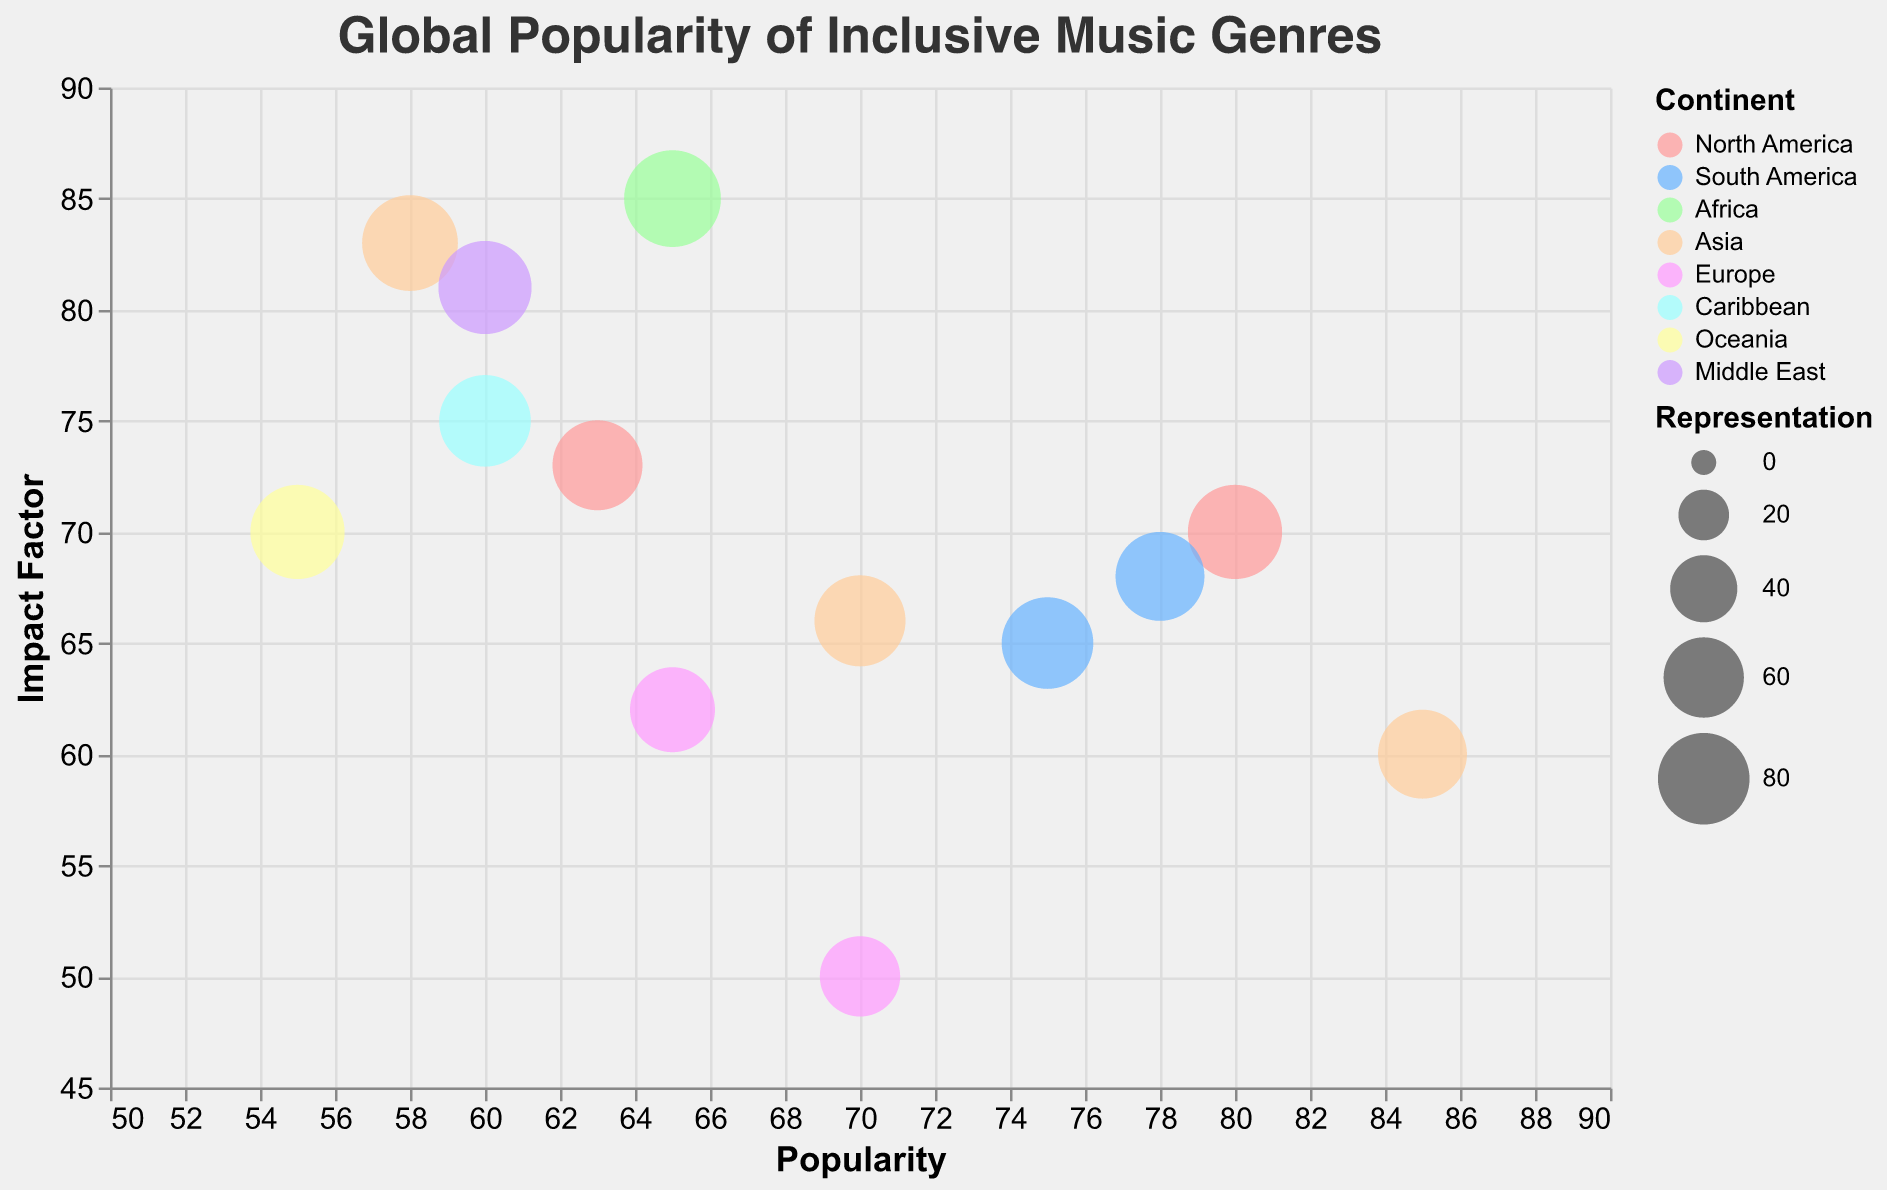What is the title of the chart? The title is usually at the top of the chart, and in this figure, it is "Global Popularity of Inclusive Music Genres".
Answer: Global Popularity of Inclusive Music Genres Which music genre has the highest popularity? To find the music genre with the highest popularity, check the x-axis values and identify the bubble that is furthest to the right. The genre "K-Pop" has the highest popularity at a value of 85.
Answer: K-Pop How many genres are represented by bubbles from Asia? The color legend differentiates continents, and Asia is represented by the orange color. By counting the bubbles of this color, we can see that Asia is represented by three genres: K-Pop, Bhangra, and J-Pop.
Answer: 3 Which genre has the largest representation? The size of each bubble represents the representation value. The largest bubble on the chart corresponds to the genre "Afrobeat" with a representation value of 90.
Answer: Afrobeat Which genre from North America has a higher impact factor? North America is represented by light red bubbles. By comparing the Impact Factor values on the y-axis for "Hip Hop" and "Gospel", we see that "Hip Hop" has an impact factor of 70 while "Gospel" has 73. Thus, "Gospel" has the higher impact factor.
Answer: Gospel Out of Latin Pop and Tropical House, which one has higher popularity and by how much? Compare their x-axis positions (Popularity). Latin Pop has a popularity of 78, and Tropical House has 65. Subtract 65 from 78 to find the difference, which is 13.
Answer: Latin Pop by 13 What is the average Impact Factor of the genres from Europe? Identify the genres from Europe (Pop and Tropical House) and their impact factors (50 and 62). Add the values (50 + 62 = 112) and divide by the number of genres (2), resulting in an average of 56.
Answer: 56 Which genre in the Caribbean has a lower popularity than Indigenous Music in Oceania? Indigenous Music in Oceania has a popularity of 55. The Caribbean genre is Dancehall, which has a popularity of 60. Since 60 is greater than 55, no Caribbean genre has a lower popularity than Indigenous Music.
Answer: None How does the representation of K-Pop compare to Dancehall? To compare their representations, look at their bubble sizes. K-Pop has a representation of 75 and Dancehall has 80. Dancehall has a higher representation than K-Pop.
Answer: Dancehall has higher representation Which genre has the highest impact factor in Asia? Compare the y-axis values (Impact Factor) for the genres from Asia (K-Pop, Bhangra, J-Pop). Their values are 60, 83, and 66 respectively, making Bhangra the genre with the highest impact factor.
Answer: Bhangra 